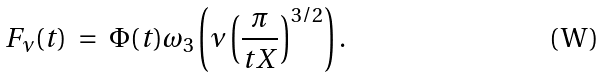<formula> <loc_0><loc_0><loc_500><loc_500>F _ { \nu } ( t ) \ = \ \Phi ( t ) \omega _ { 3 } \left ( \nu \left ( \frac { \pi } { t X } \right ) ^ { 3 / 2 } \right ) .</formula> 